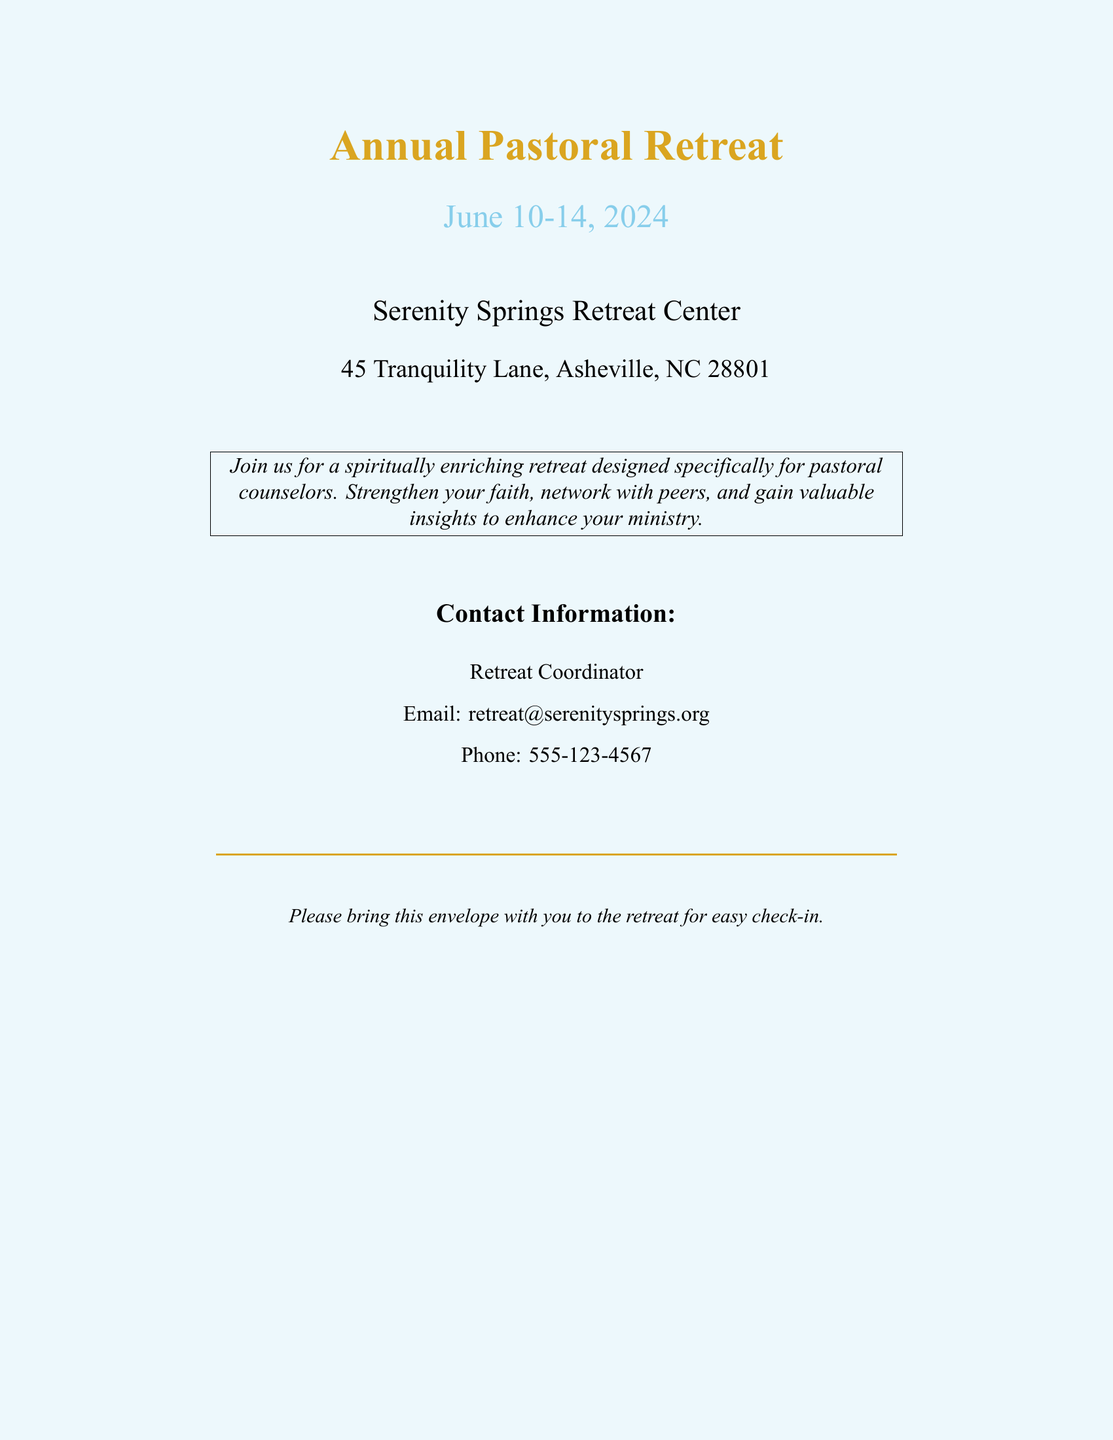What are the dates of the retreat? The dates of the retreat are specified in the document as June 10-14, 2024.
Answer: June 10-14, 2024 What is the name of the retreat center? The document states that the retreat will be held at Serenity Springs Retreat Center.
Answer: Serenity Springs Retreat Center What is the contact email for the retreat? The contact information section provides the email address for the retreat as retreat@serenitysprings.org.
Answer: retreat@serenitysprings.org What is the address of the retreat center? The document lists the address as 45 Tranquility Lane, Asheville, NC 28801.
Answer: 45 Tranquility Lane, Asheville, NC 28801 Who is the retreat coordinator? The document provides information that the contact point is the Retreat Coordinator, although no specific name is given.
Answer: Retreat Coordinator What should attendees bring to the retreat? The document instructs attendees to bring the envelope for easy check-in at the retreat.
Answer: This envelope What type of event is the retreat designed for? The retreat is specifically designed for pastoral counselors, as mentioned in the document.
Answer: Pastoral counselors Where is Serenity Springs Retreat Center located? The provided address indicates that the location is in Asheville, NC.
Answer: Asheville, NC What is the main purpose of the retreat? The document states that the retreat is aimed to spiritually enrich participants and strengthen their faith.
Answer: Spiritually enriching 